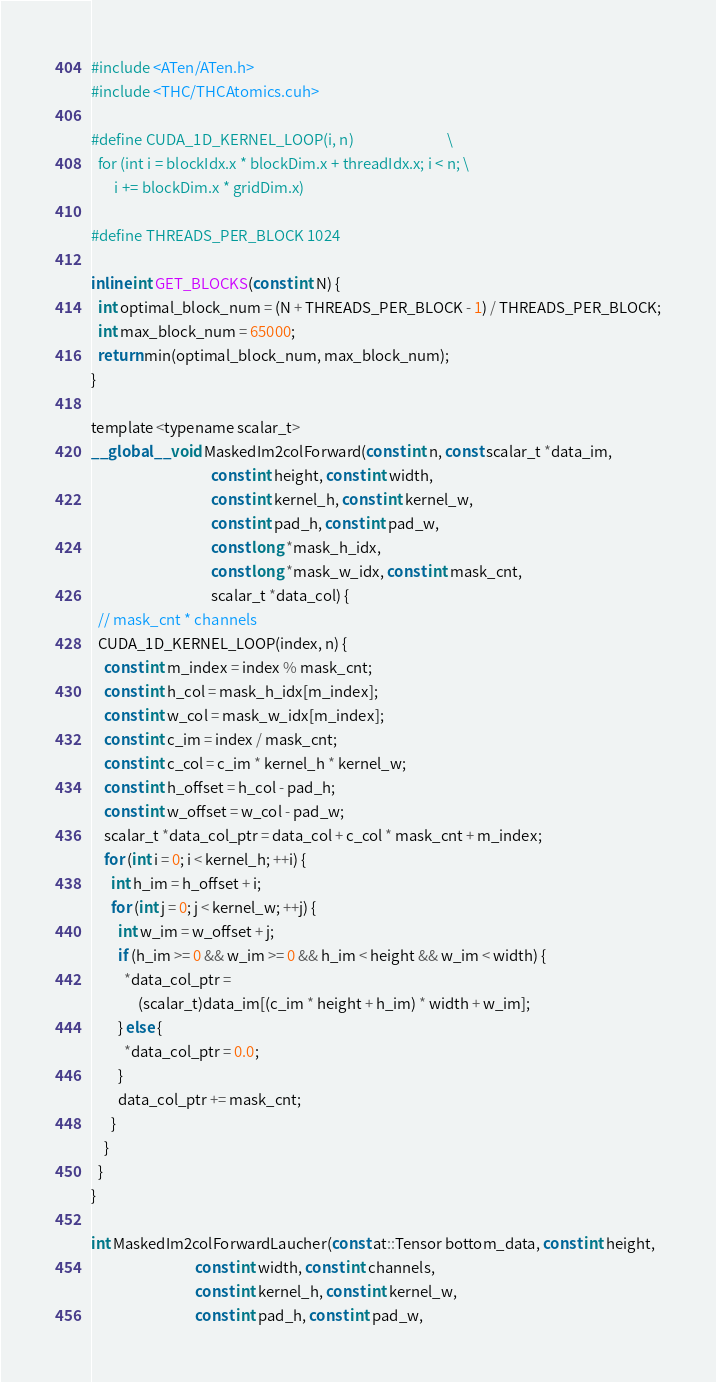<code> <loc_0><loc_0><loc_500><loc_500><_Cuda_>#include <ATen/ATen.h>
#include <THC/THCAtomics.cuh>

#define CUDA_1D_KERNEL_LOOP(i, n)                            \
  for (int i = blockIdx.x * blockDim.x + threadIdx.x; i < n; \
       i += blockDim.x * gridDim.x)

#define THREADS_PER_BLOCK 1024

inline int GET_BLOCKS(const int N) {
  int optimal_block_num = (N + THREADS_PER_BLOCK - 1) / THREADS_PER_BLOCK;
  int max_block_num = 65000;
  return min(optimal_block_num, max_block_num);
}

template <typename scalar_t>
__global__ void MaskedIm2colForward(const int n, const scalar_t *data_im,
                                    const int height, const int width,
                                    const int kernel_h, const int kernel_w,
                                    const int pad_h, const int pad_w,
                                    const long *mask_h_idx,
                                    const long *mask_w_idx, const int mask_cnt,
                                    scalar_t *data_col) {
  // mask_cnt * channels
  CUDA_1D_KERNEL_LOOP(index, n) {
    const int m_index = index % mask_cnt;
    const int h_col = mask_h_idx[m_index];
    const int w_col = mask_w_idx[m_index];
    const int c_im = index / mask_cnt;
    const int c_col = c_im * kernel_h * kernel_w;
    const int h_offset = h_col - pad_h;
    const int w_offset = w_col - pad_w;
    scalar_t *data_col_ptr = data_col + c_col * mask_cnt + m_index;
    for (int i = 0; i < kernel_h; ++i) {
      int h_im = h_offset + i;
      for (int j = 0; j < kernel_w; ++j) {
        int w_im = w_offset + j;
        if (h_im >= 0 && w_im >= 0 && h_im < height && w_im < width) {
          *data_col_ptr =
              (scalar_t)data_im[(c_im * height + h_im) * width + w_im];
        } else {
          *data_col_ptr = 0.0;
        }
        data_col_ptr += mask_cnt;
      }
    }
  }
}

int MaskedIm2colForwardLaucher(const at::Tensor bottom_data, const int height,
                               const int width, const int channels,
                               const int kernel_h, const int kernel_w,
                               const int pad_h, const int pad_w,</code> 